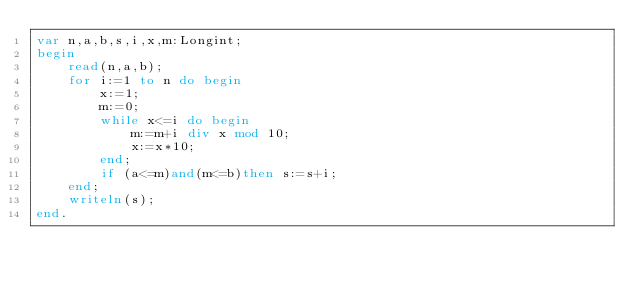<code> <loc_0><loc_0><loc_500><loc_500><_Pascal_>var n,a,b,s,i,x,m:Longint;
begin
	read(n,a,b);
	for i:=1 to n do begin
		x:=1;
		m:=0;
		while x<=i do begin
			m:=m+i div x mod 10;
			x:=x*10;
		end;
		if (a<=m)and(m<=b)then s:=s+i;
	end;
	writeln(s);
end.
</code> 